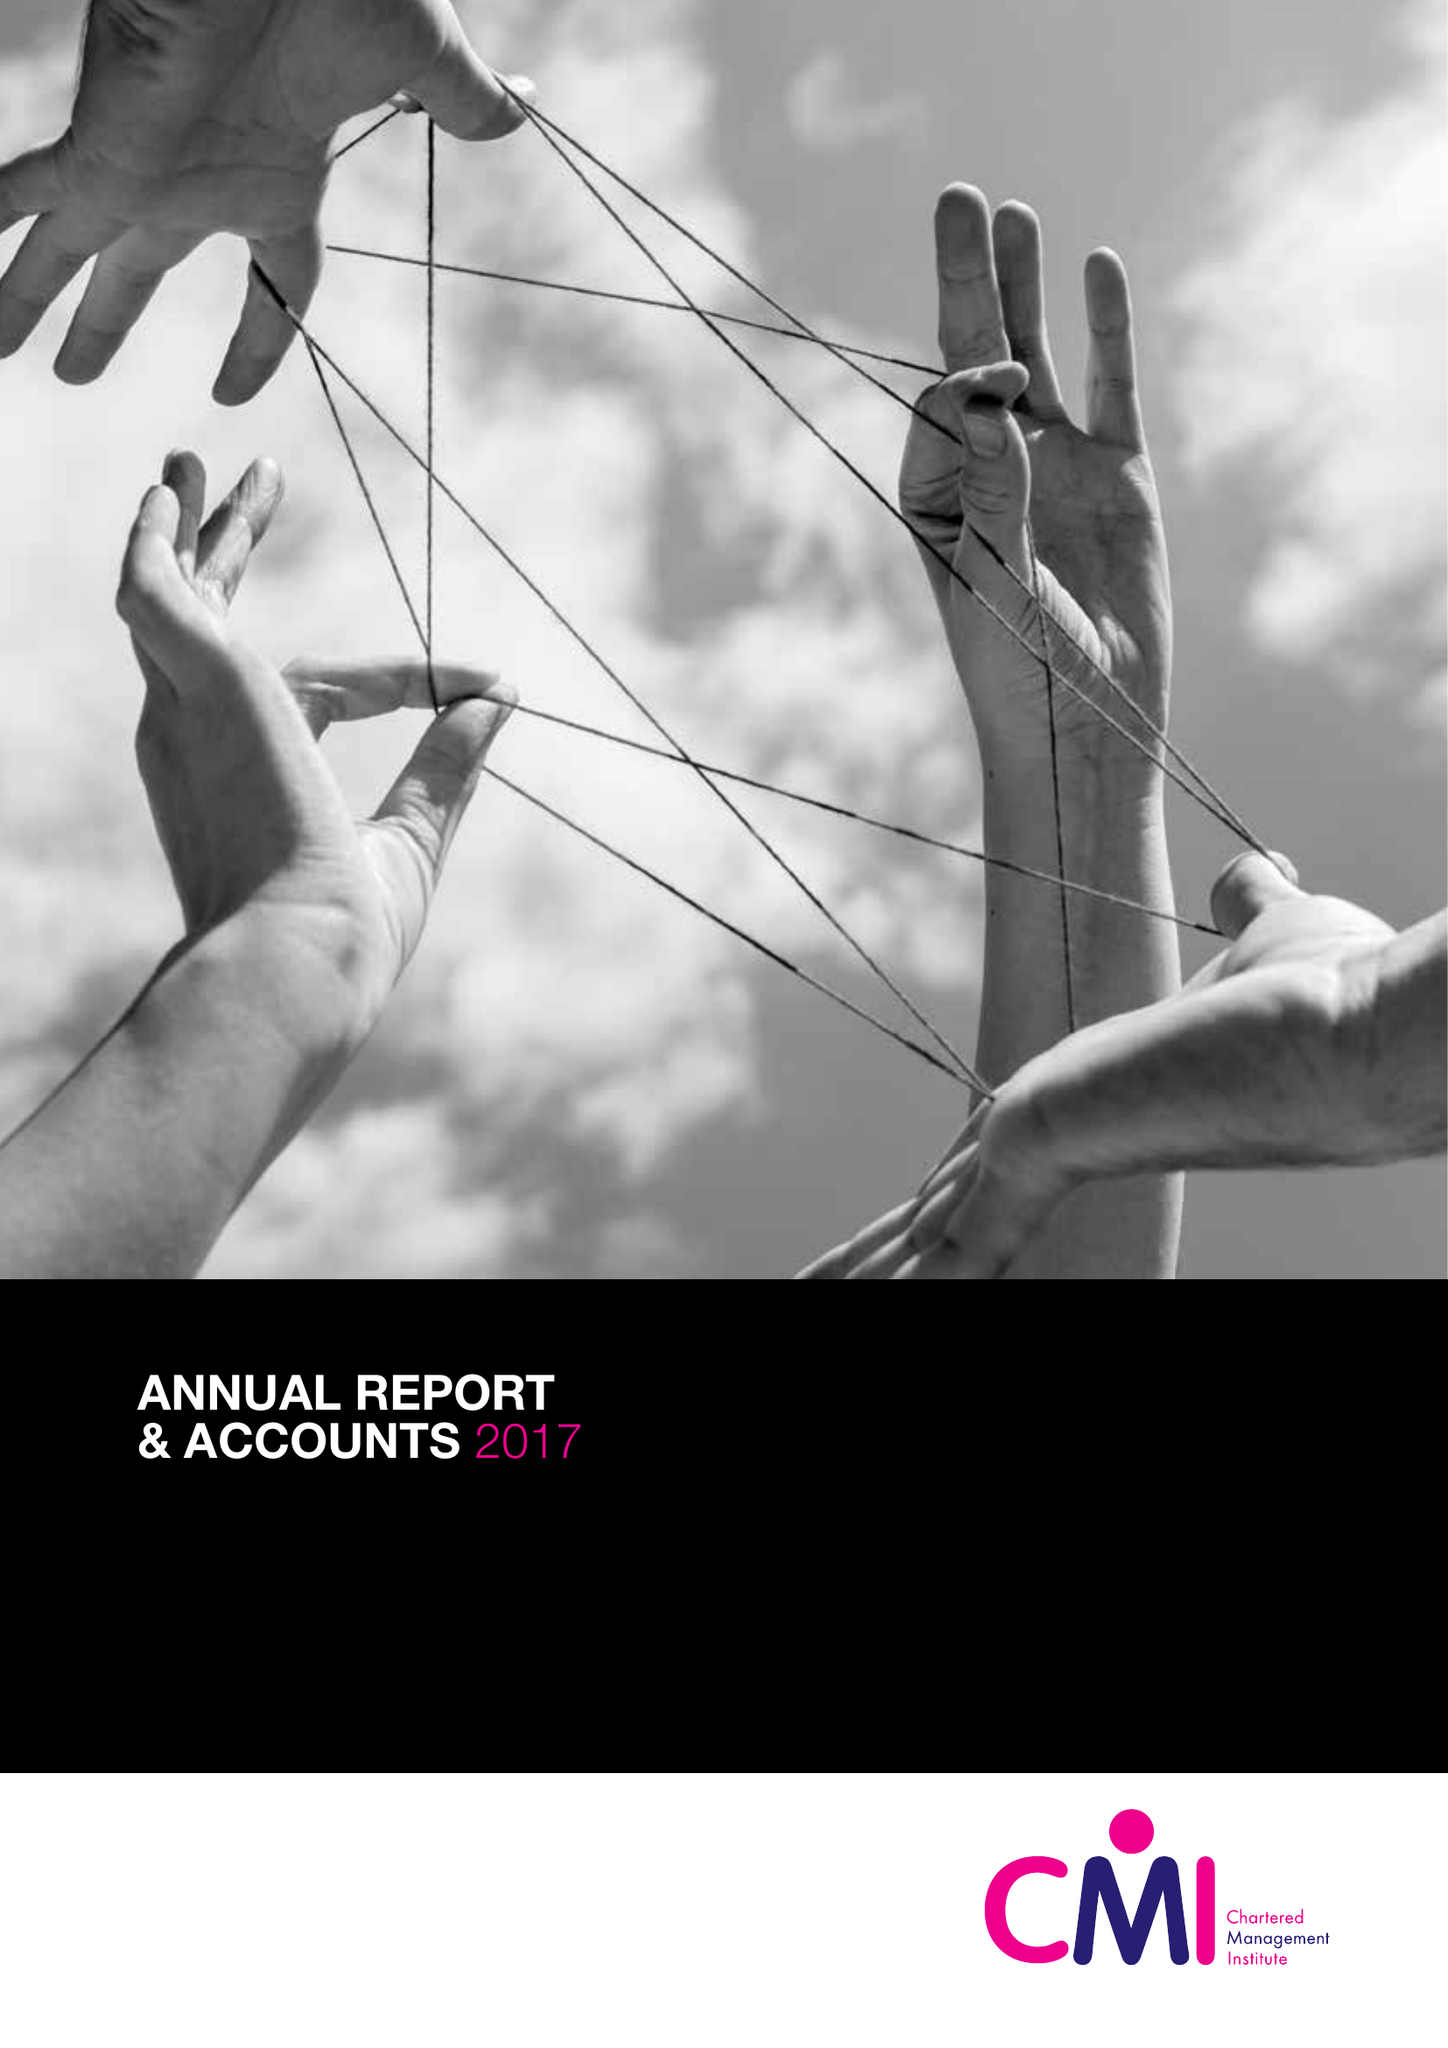What is the value for the address__post_town?
Answer the question using a single word or phrase. CORBY 